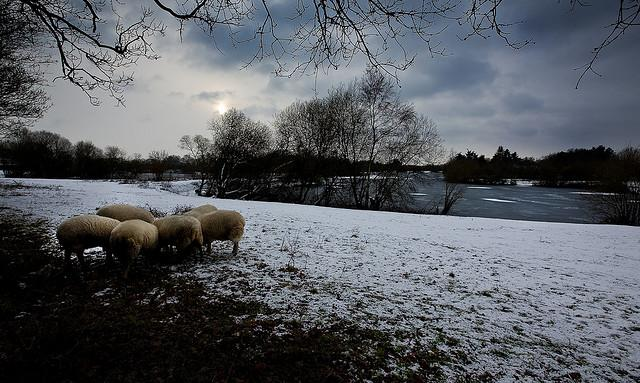These animals are in a formation that is reminiscent of what sport? Please explain your reasoning. football. The sheep are huddling each other. 